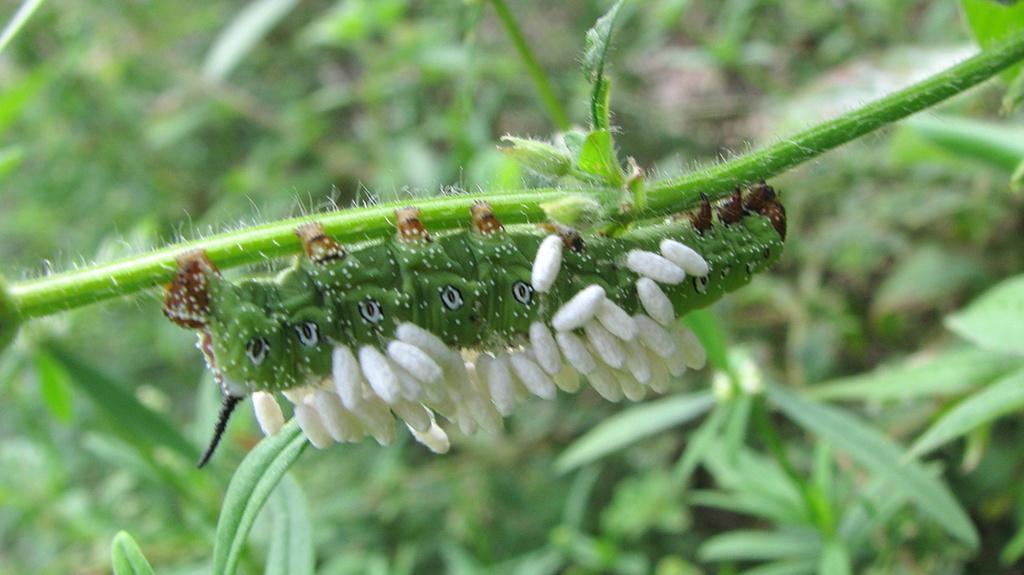Can you describe this image briefly? In this image we can see an insect on the plant and we can see some plants and in the background, the image is blurred. 